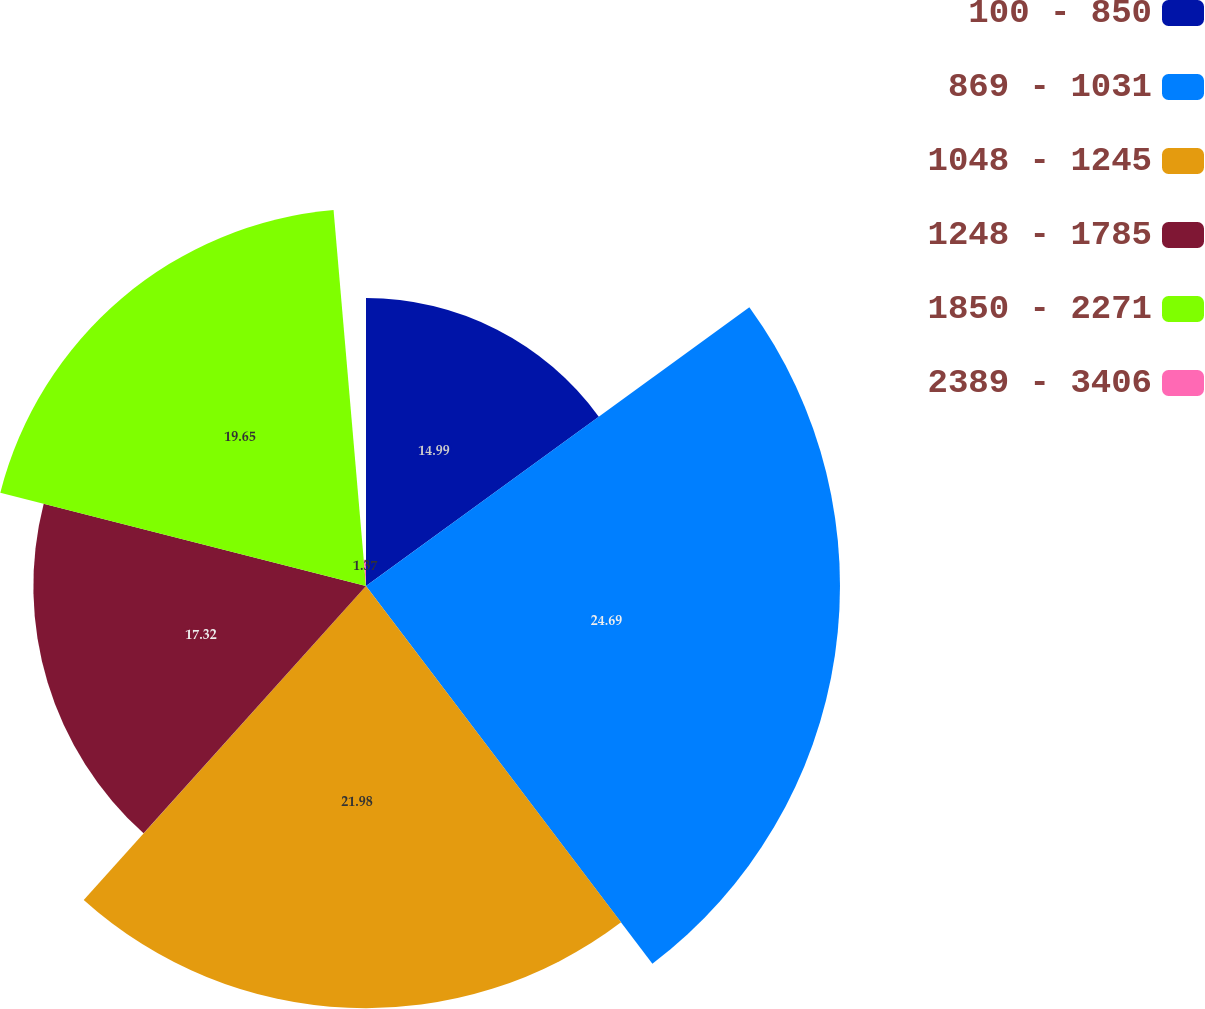<chart> <loc_0><loc_0><loc_500><loc_500><pie_chart><fcel>100 - 850<fcel>869 - 1031<fcel>1048 - 1245<fcel>1248 - 1785<fcel>1850 - 2271<fcel>2389 - 3406<nl><fcel>14.99%<fcel>24.68%<fcel>21.98%<fcel>17.32%<fcel>19.65%<fcel>1.37%<nl></chart> 